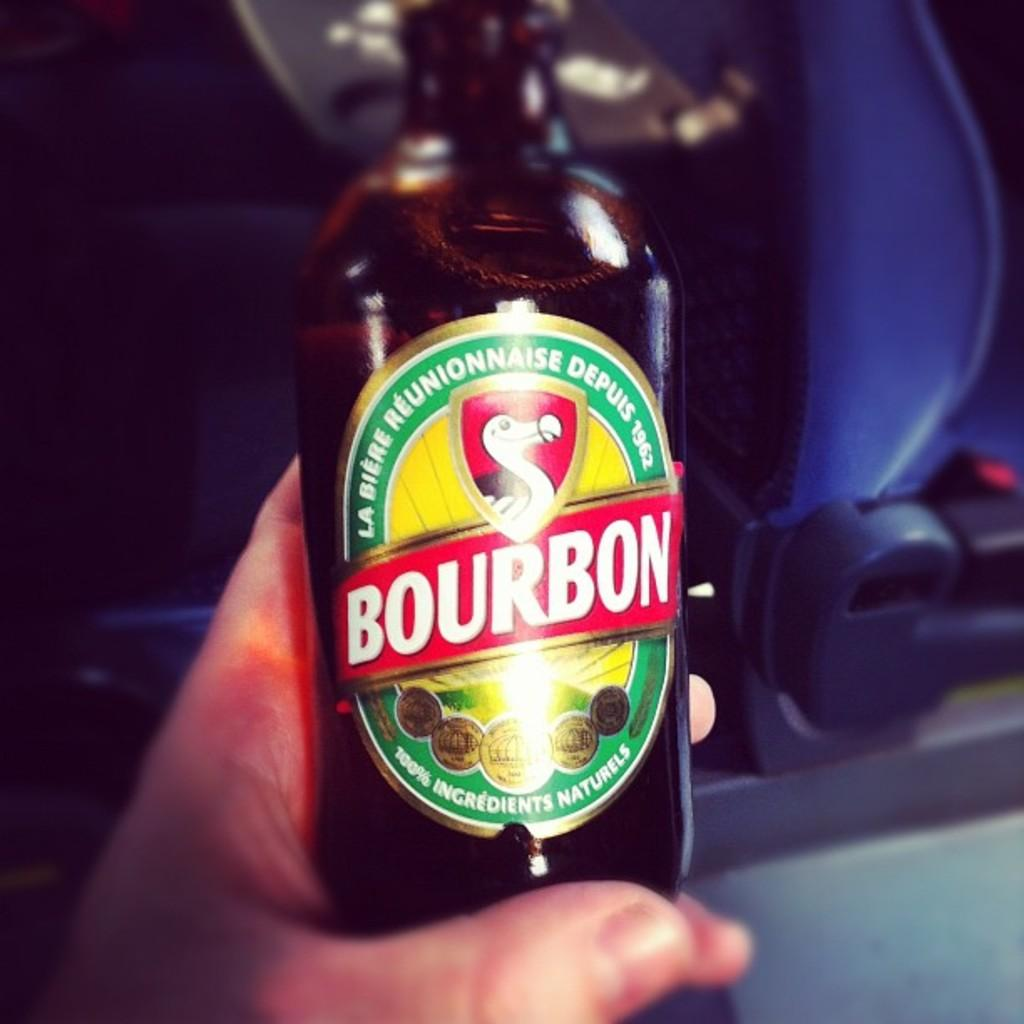Provide a one-sentence caption for the provided image. A bottle of alcohol has the word Bourbon on its label. 